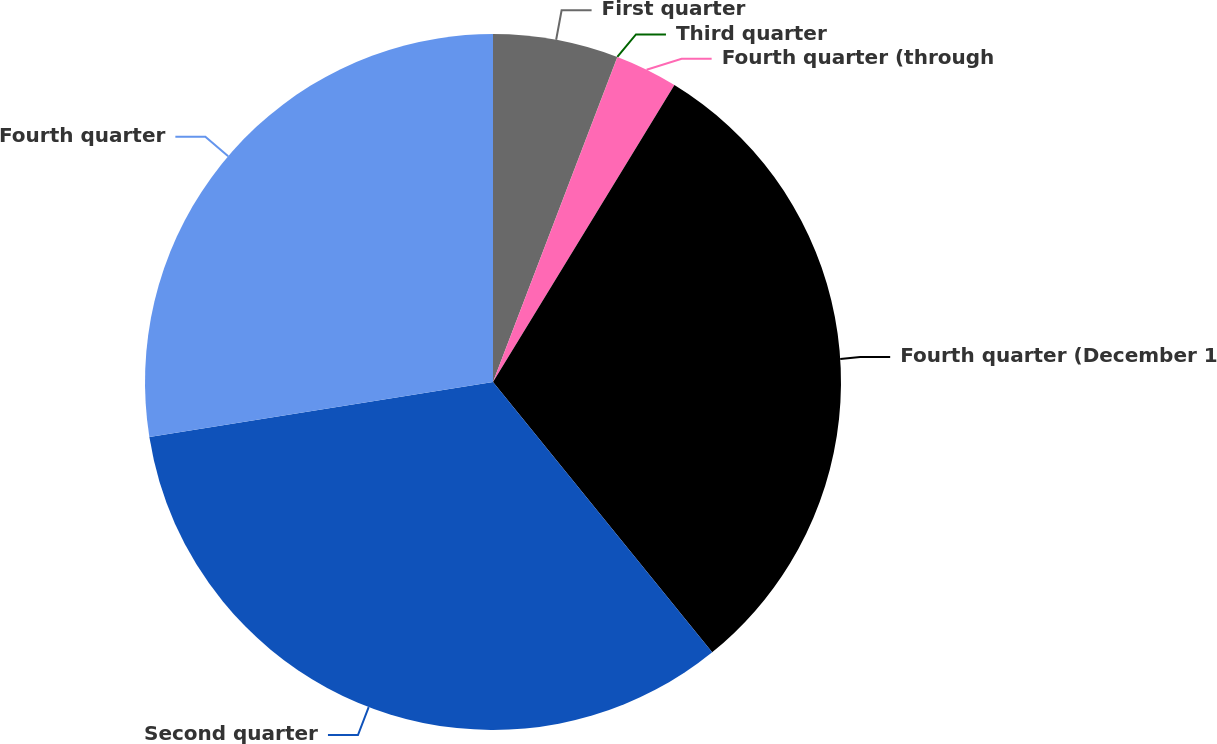Convert chart to OTSL. <chart><loc_0><loc_0><loc_500><loc_500><pie_chart><fcel>First quarter<fcel>Third quarter<fcel>Fourth quarter (through<fcel>Fourth quarter (December 1<fcel>Second quarter<fcel>Fourth quarter<nl><fcel>5.81%<fcel>0.01%<fcel>2.91%<fcel>30.43%<fcel>33.32%<fcel>27.53%<nl></chart> 